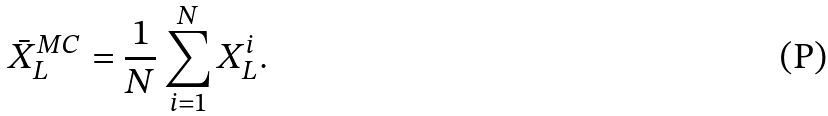Convert formula to latex. <formula><loc_0><loc_0><loc_500><loc_500>\bar { X } _ { L } ^ { M C } = \frac { 1 } { N } \sum ^ { N } _ { i = 1 } X _ { L } ^ { i } .</formula> 